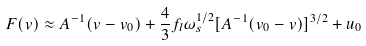<formula> <loc_0><loc_0><loc_500><loc_500>F ( v ) \approx A ^ { - 1 } ( v - v _ { 0 } ) + \frac { 4 } { 3 } f _ { l } \omega _ { s } ^ { 1 / 2 } [ A ^ { - 1 } ( v _ { 0 } - v ) ] ^ { 3 / 2 } + u _ { 0 }</formula> 